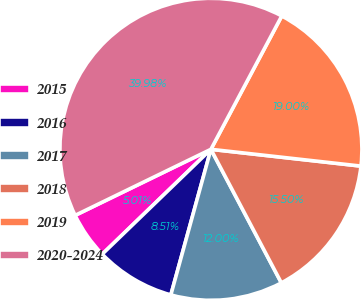<chart> <loc_0><loc_0><loc_500><loc_500><pie_chart><fcel>2015<fcel>2016<fcel>2017<fcel>2018<fcel>2019<fcel>2020-2024<nl><fcel>5.01%<fcel>8.51%<fcel>12.0%<fcel>15.5%<fcel>19.0%<fcel>39.98%<nl></chart> 